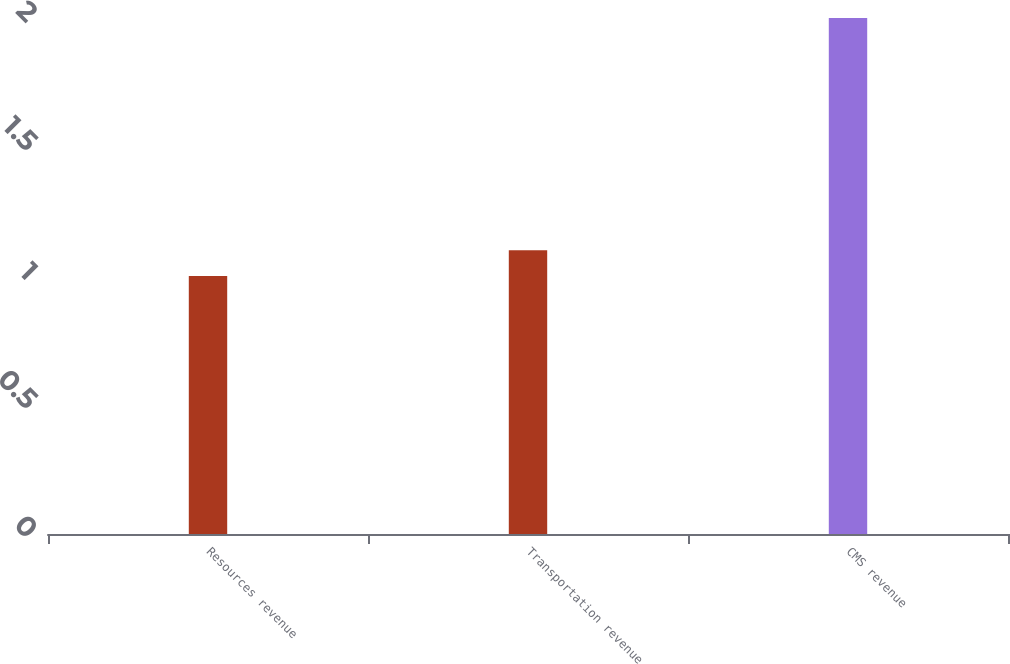Convert chart to OTSL. <chart><loc_0><loc_0><loc_500><loc_500><bar_chart><fcel>Resources revenue<fcel>Transportation revenue<fcel>CMS revenue<nl><fcel>1<fcel>1.1<fcel>2<nl></chart> 